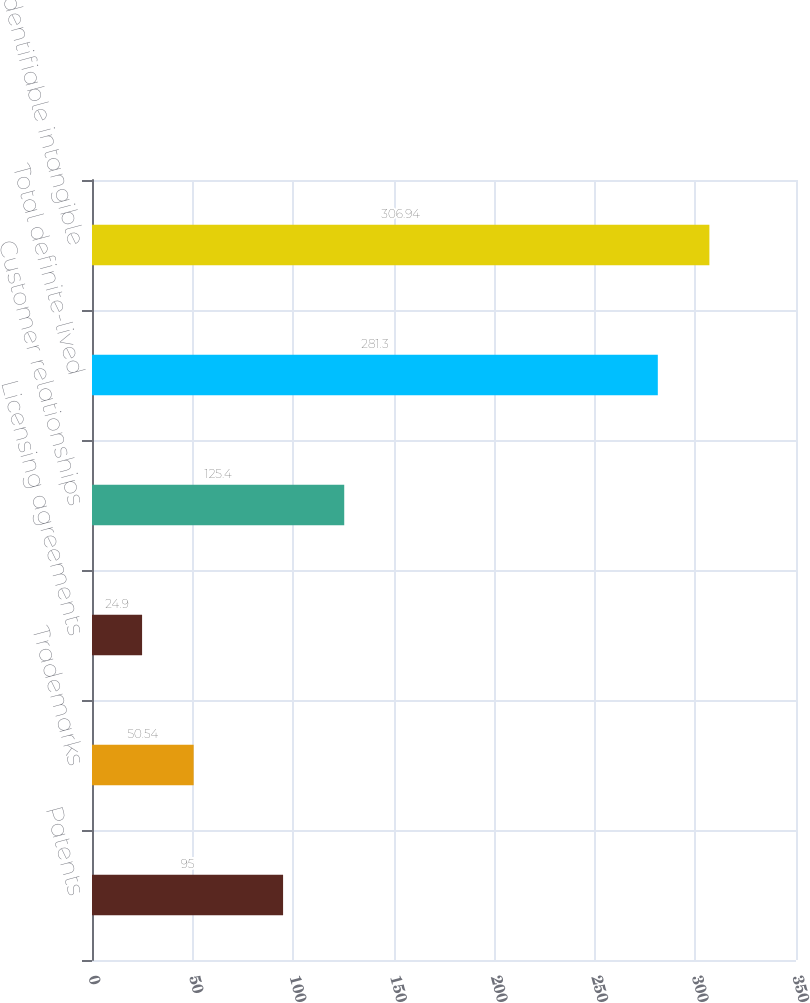Convert chart. <chart><loc_0><loc_0><loc_500><loc_500><bar_chart><fcel>Patents<fcel>Trademarks<fcel>Licensing agreements<fcel>Customer relationships<fcel>Total definite-lived<fcel>Total identifiable intangible<nl><fcel>95<fcel>50.54<fcel>24.9<fcel>125.4<fcel>281.3<fcel>306.94<nl></chart> 